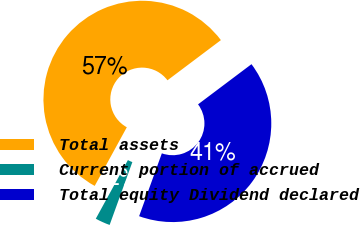Convert chart to OTSL. <chart><loc_0><loc_0><loc_500><loc_500><pie_chart><fcel>Total assets<fcel>Current portion of accrued<fcel>Total equity Dividend declared<nl><fcel>56.76%<fcel>2.45%<fcel>40.78%<nl></chart> 